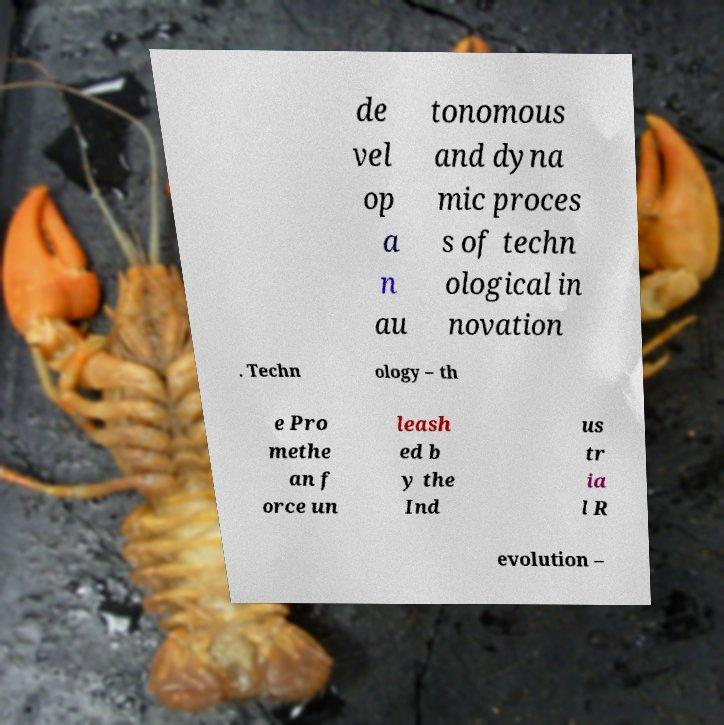I need the written content from this picture converted into text. Can you do that? de vel op a n au tonomous and dyna mic proces s of techn ological in novation . Techn ology – th e Pro methe an f orce un leash ed b y the Ind us tr ia l R evolution – 